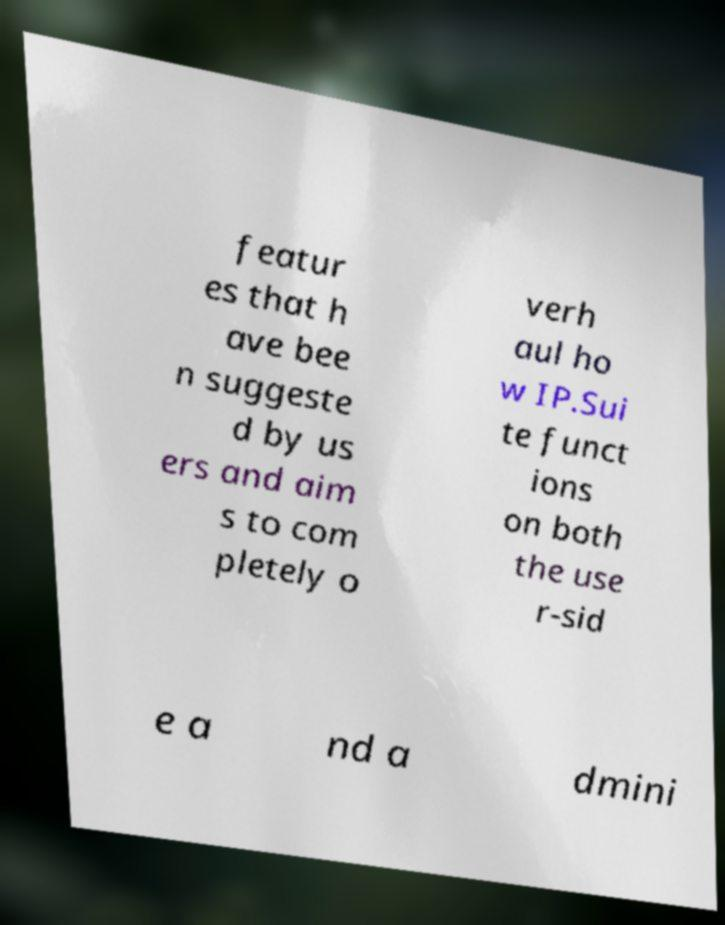Can you accurately transcribe the text from the provided image for me? featur es that h ave bee n suggeste d by us ers and aim s to com pletely o verh aul ho w IP.Sui te funct ions on both the use r-sid e a nd a dmini 